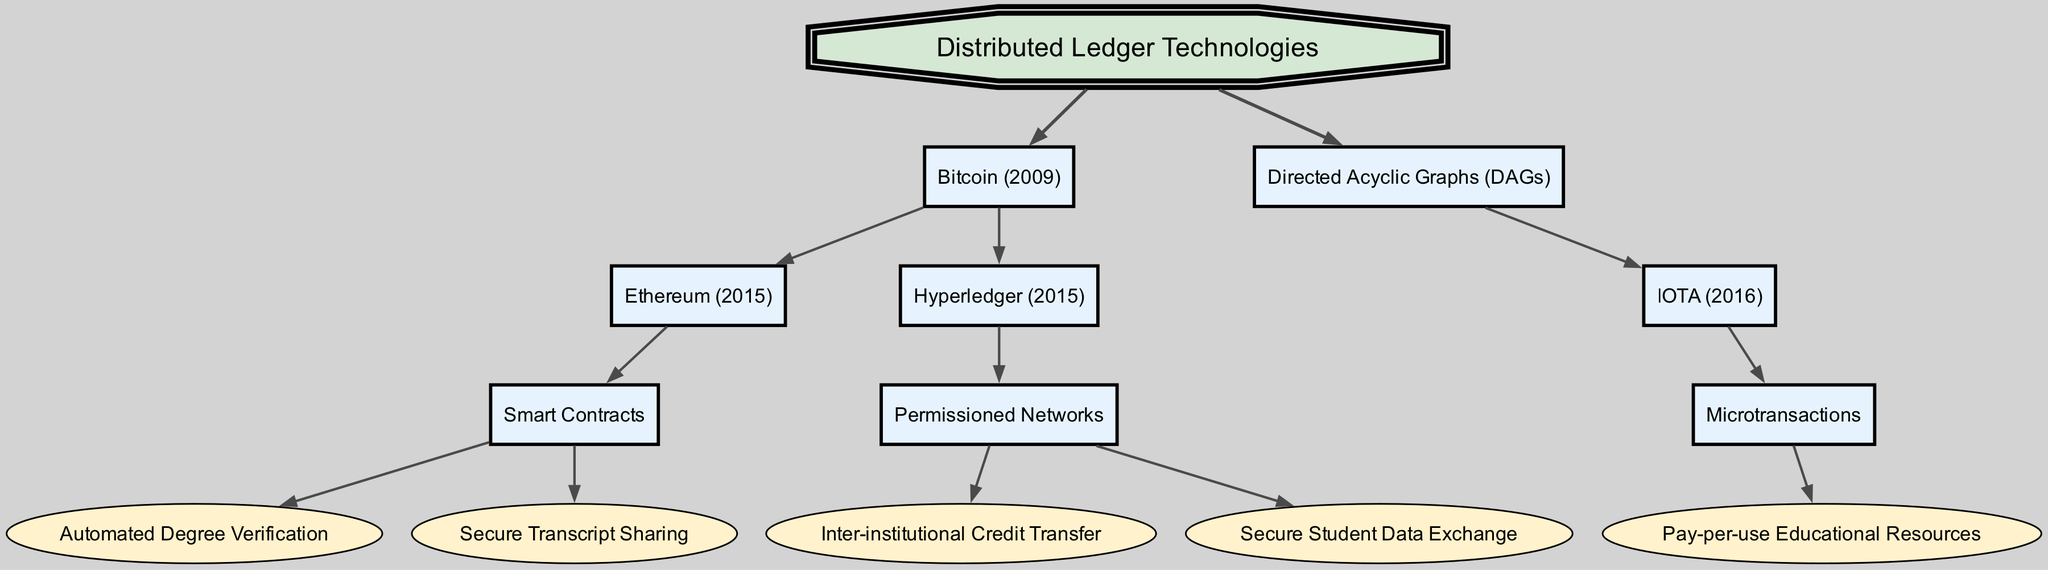What is the root node of the diagram? The root node is explicitly labeled in the diagram. By reviewing the topmost node, it can be determined that the root is "Distributed Ledger Technologies."
Answer: Distributed Ledger Technologies How many main branches does the diagram have? The branches originate from the root node, and upon inspection, there are two main branches: one for "Bitcoin" and one for "Directed Acyclic Graphs (DAGs)." Thus, the total is two.
Answer: 2 What technology was introduced first, Bitcoin or Ethereum? Looking at the nodes, "Bitcoin" is listed as originating in 2009, while "Ethereum" is introduced later in 2015. Therefore, Bitcoin is the first technology.
Answer: Bitcoin How many uses are listed under Smart Contracts? By examining the children of the "Smart Contracts" node, two applications are seen: "Automated Degree Verification" and "Secure Transcript Sharing." Hence, there are two listed uses.
Answer: 2 What is one potential use of IOTA mentioned in the diagram? The diagram shows that "IOTA" has a direct child labeled "Microtransactions," which further has a potential use called "Pay-per-use Educational Resources." Thus, that is one of the potential uses.
Answer: Pay-per-use Educational Resources Which technology allows for "Secure Student Data Exchange"? To find this, track the connections from "Secure Student Data Exchange." It is a child node under "Permissioned Networks," which is itself a child of "Hyperledger." This pathway indicates that "Hyperledger" is the technology that allows this use.
Answer: Hyperledger What type of networks does "Hyperledger" utilize? From the diagram, "Hyperledger" has a child node labeled "Permissioned Networks." Consequently, the type of networks utilized by "Hyperledger" can be directly inferred.
Answer: Permissioned Networks Which blockchain technology focuses on microtransactions? The node labeled "IOTA" explicitly mentions microtransactions as one of its key features within the diagram. Therefore, IOTA is the technology focusing on that aspect.
Answer: IOTA How many technologies are shown as children of Bitcoin? By examining the children of the "Bitcoin" node, there are two immediate children: "Ethereum" and "Hyperledger." Counting these reveals that there are two technologies.
Answer: 2 